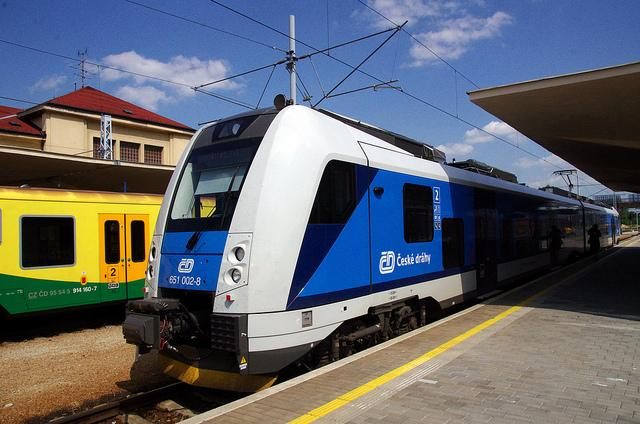Where is the train from? czech republic 